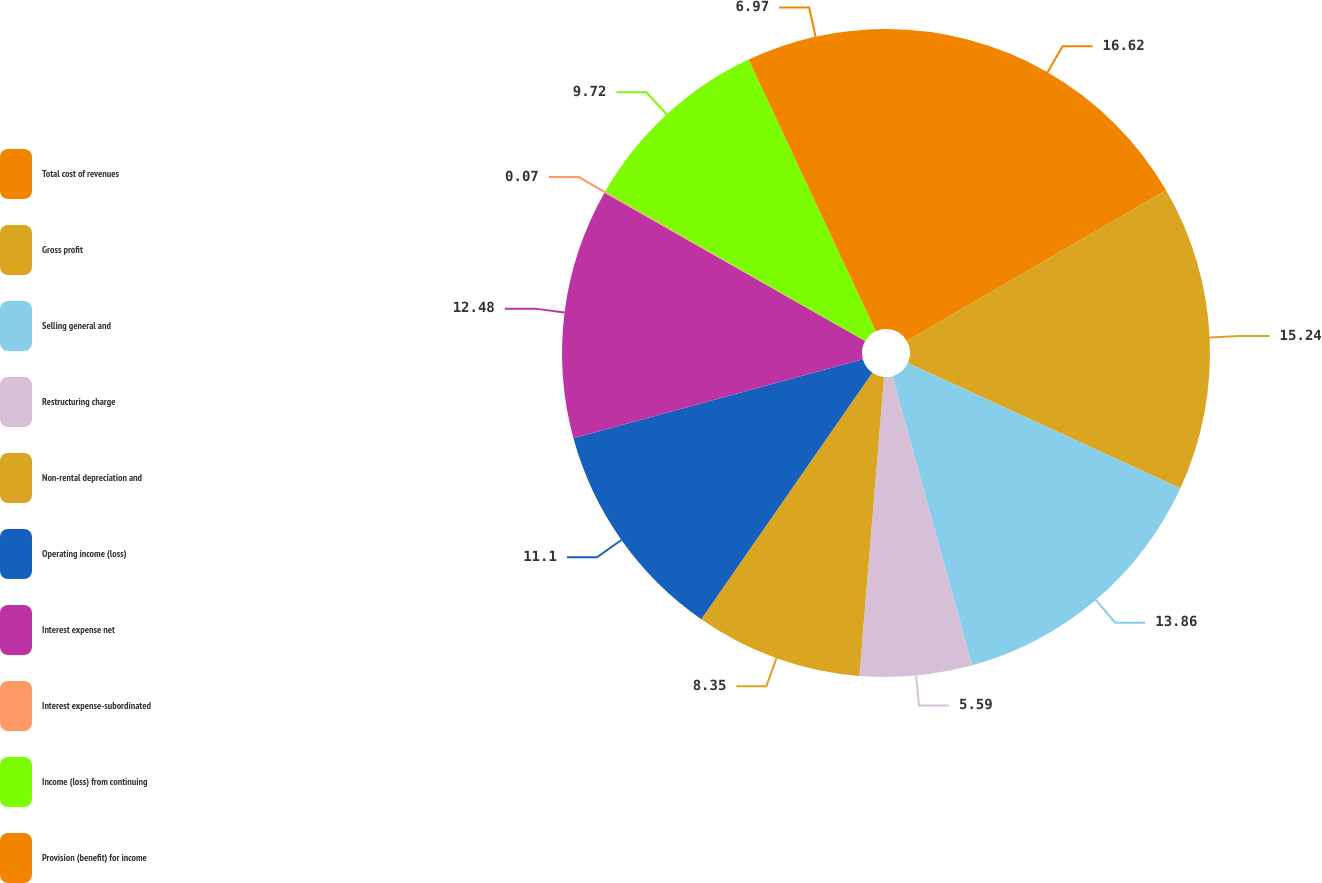<chart> <loc_0><loc_0><loc_500><loc_500><pie_chart><fcel>Total cost of revenues<fcel>Gross profit<fcel>Selling general and<fcel>Restructuring charge<fcel>Non-rental depreciation and<fcel>Operating income (loss)<fcel>Interest expense net<fcel>Interest expense-subordinated<fcel>Income (loss) from continuing<fcel>Provision (benefit) for income<nl><fcel>16.62%<fcel>15.24%<fcel>13.86%<fcel>5.59%<fcel>8.35%<fcel>11.1%<fcel>12.48%<fcel>0.07%<fcel>9.72%<fcel>6.97%<nl></chart> 